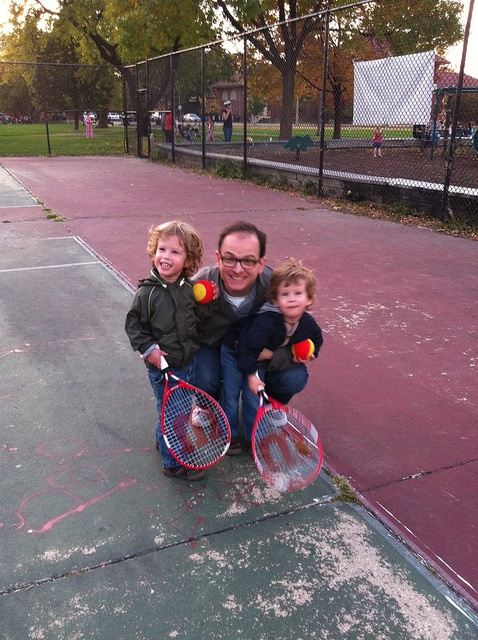Describe the objects in this image and their specific colors. I can see people in ivory, black, navy, gray, and brown tones, people in ivory, black, navy, brown, and lightpink tones, people in ivory, black, brown, lightpink, and maroon tones, tennis racket in ivory, gray, navy, and black tones, and tennis racket in ivory, purple, brown, gray, and darkgray tones in this image. 